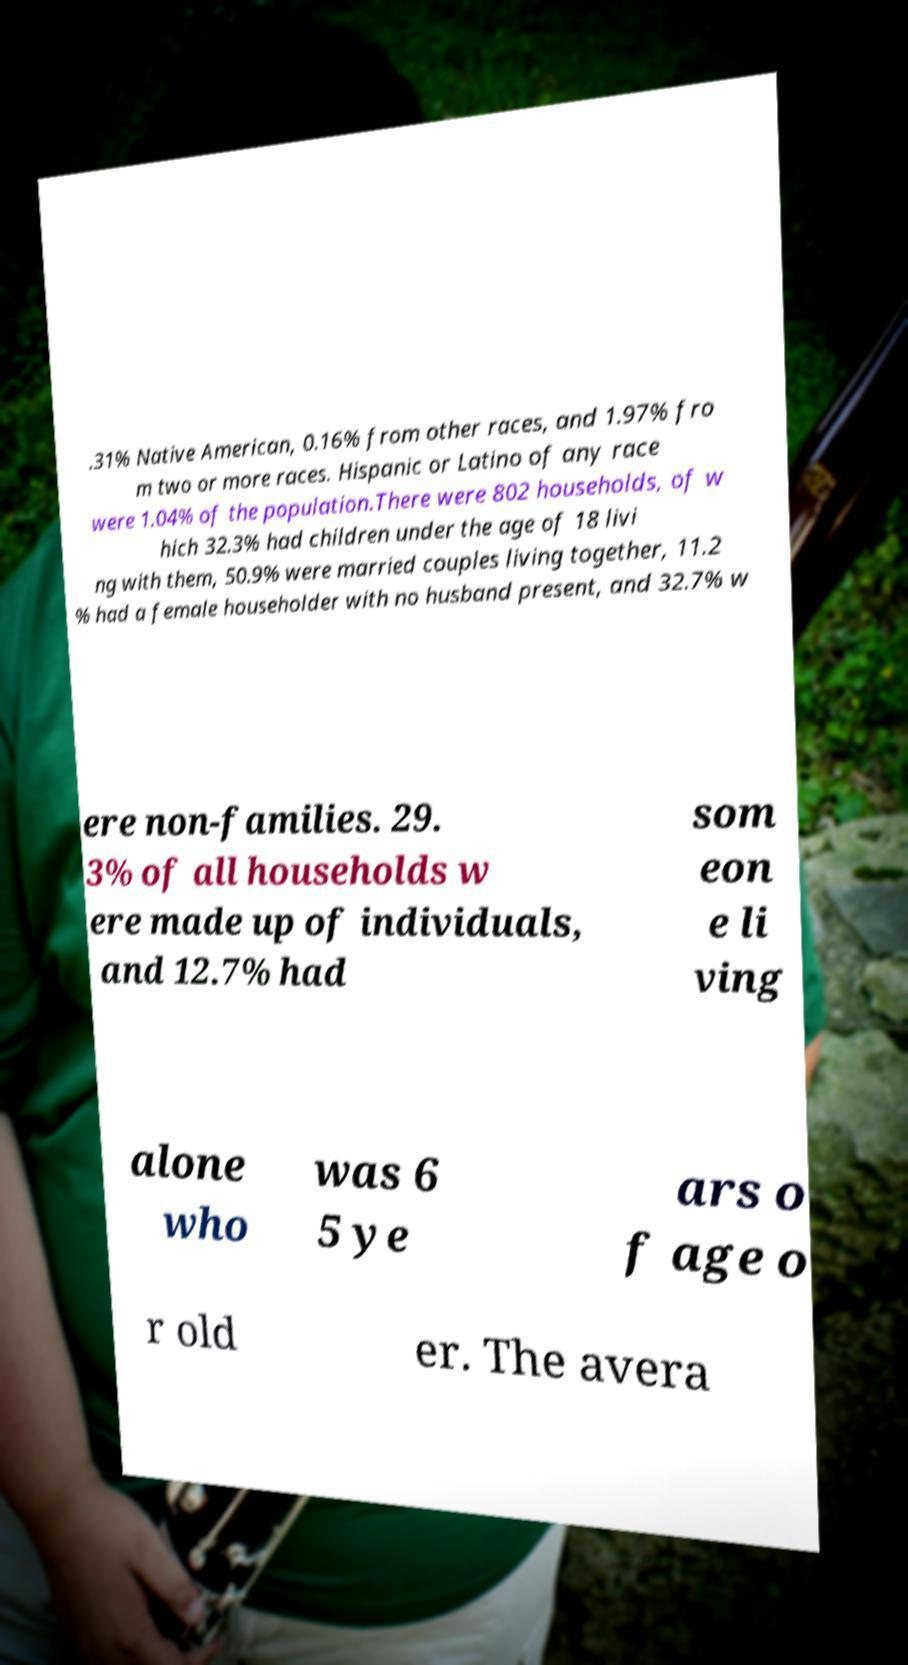Could you assist in decoding the text presented in this image and type it out clearly? .31% Native American, 0.16% from other races, and 1.97% fro m two or more races. Hispanic or Latino of any race were 1.04% of the population.There were 802 households, of w hich 32.3% had children under the age of 18 livi ng with them, 50.9% were married couples living together, 11.2 % had a female householder with no husband present, and 32.7% w ere non-families. 29. 3% of all households w ere made up of individuals, and 12.7% had som eon e li ving alone who was 6 5 ye ars o f age o r old er. The avera 